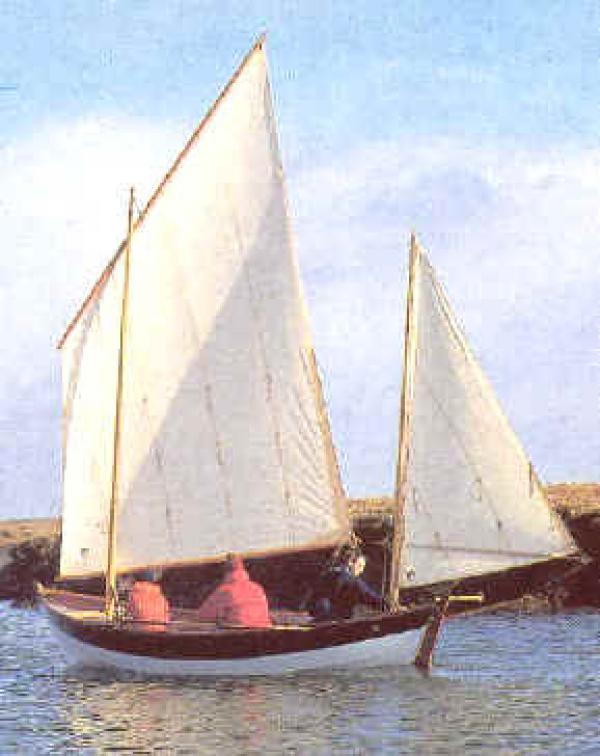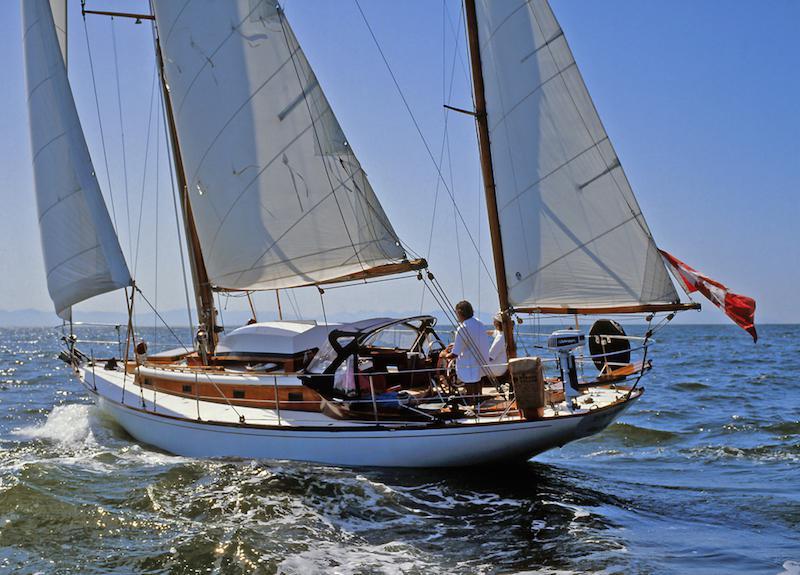The first image is the image on the left, the second image is the image on the right. Analyze the images presented: Is the assertion "There is people sailing in the center of each image." valid? Answer yes or no. Yes. The first image is the image on the left, the second image is the image on the right. Evaluate the accuracy of this statement regarding the images: "There is atleast one boat with numbers or letters on the sail". Is it true? Answer yes or no. No. 